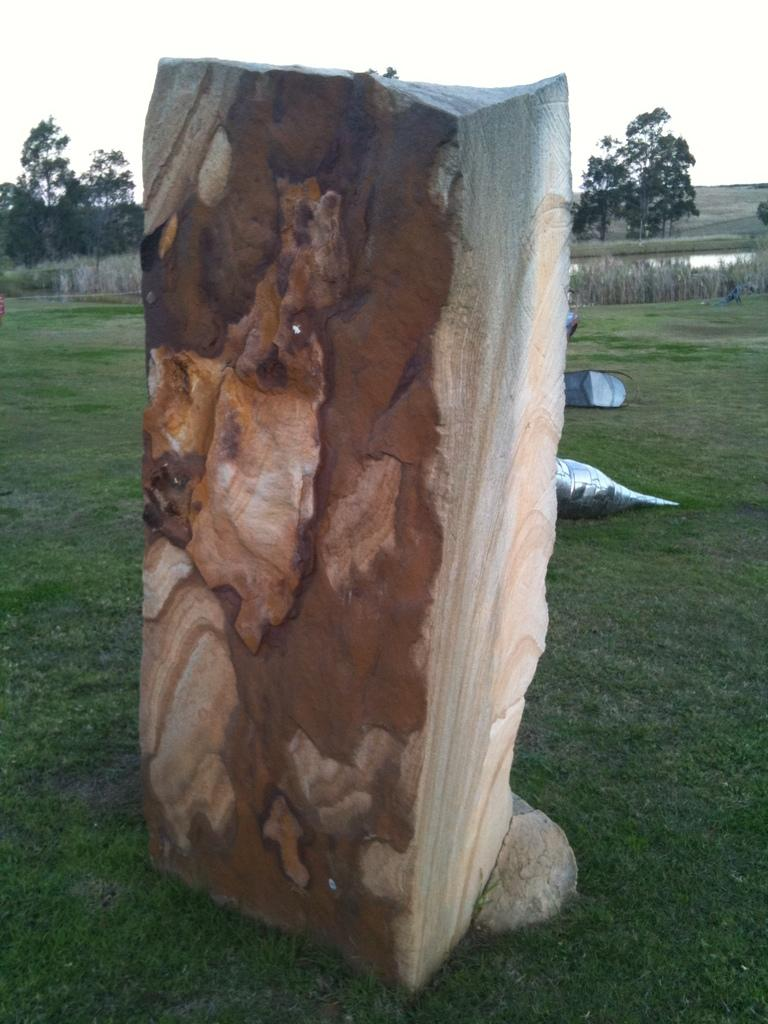What type of material is the log in the image made of? The wooden log in the image is made of wood. What type of vegetation can be seen in the image? There is grass, plants, and trees visible in the image. What natural element is present in the image? Water is visible in the image. What is visible in the background of the image? The sky is visible in the background of the image. What type of glass can be seen in the image? There is no glass present in the image. What is the desire of the plants in the image? Plants do not have desires, so this question cannot be answered. 